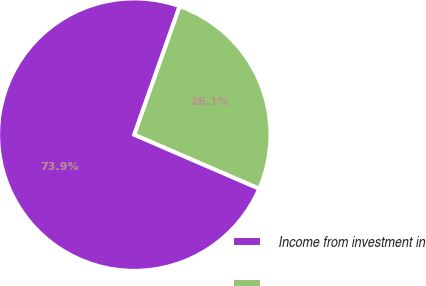Convert chart. <chart><loc_0><loc_0><loc_500><loc_500><pie_chart><fcel>Income from investment in<fcel>Unnamed: 1<nl><fcel>73.91%<fcel>26.09%<nl></chart> 